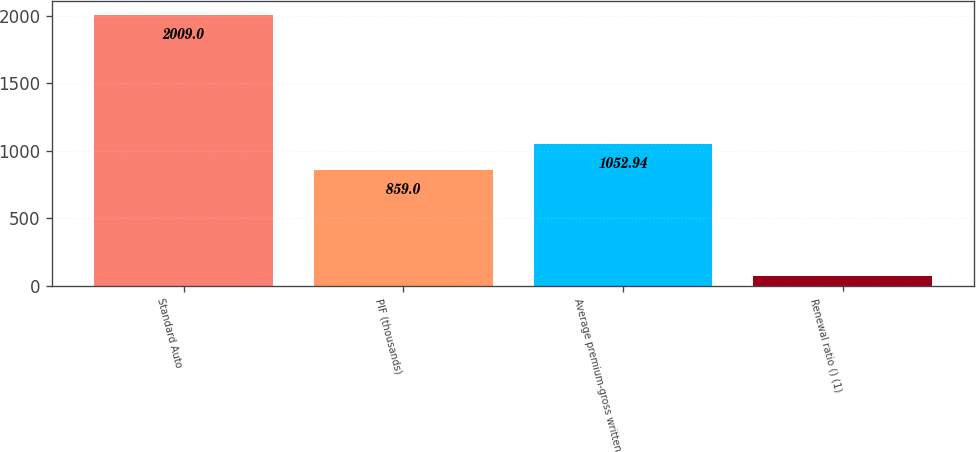Convert chart to OTSL. <chart><loc_0><loc_0><loc_500><loc_500><bar_chart><fcel>Standard Auto<fcel>PIF (thousands)<fcel>Average premium-gross written<fcel>Renewal ratio () (1)<nl><fcel>2009<fcel>859<fcel>1052.94<fcel>69.6<nl></chart> 